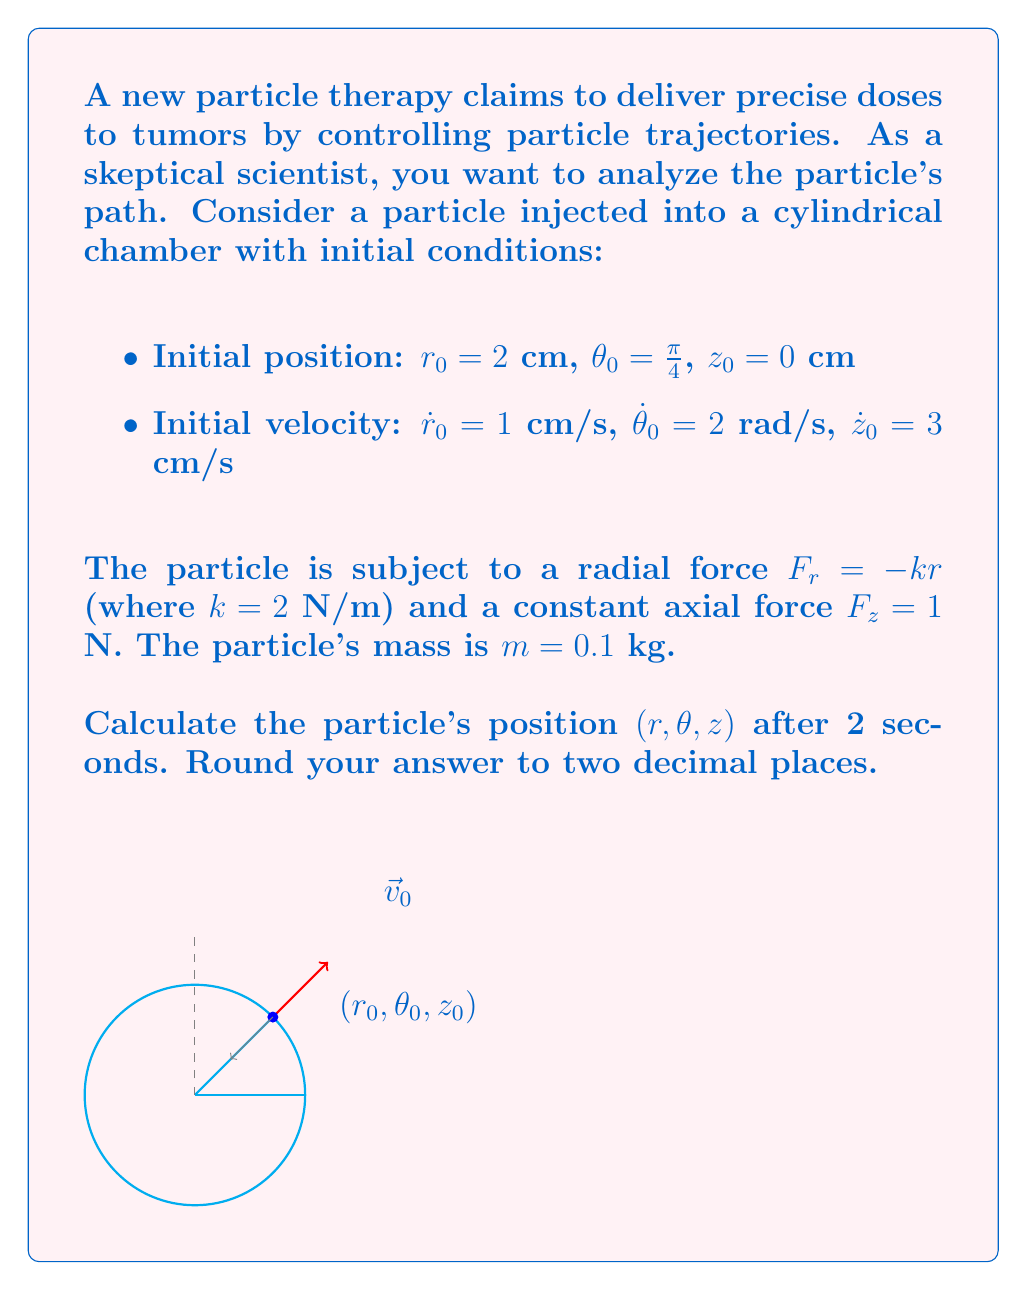Could you help me with this problem? To solve this problem, we need to use the equations of motion in cylindrical coordinates:

1) For the radial component:
   $$m(\ddot{r} - r\dot{\theta}^2) = F_r = -kr$$
   $$\ddot{r} - r\dot{\theta}^2 = -\frac{k}{m}r = -20r$$

2) For the angular component:
   $$m(r\ddot{\theta} + 2\dot{r}\dot{\theta}) = 0$$ (no angular force)
   $$r\ddot{\theta} + 2\dot{r}\dot{\theta} = 0$$

3) For the axial component:
   $$m\ddot{z} = F_z = 1$$
   $$\ddot{z} = \frac{1}{m} = 10$$

Let's solve each component:

For z:
$$\ddot{z} = 10$$
$$\dot{z} = 10t + \dot{z}_0 = 10t + 3$$
$$z = 5t^2 + 3t + z_0 = 5t^2 + 3t$$

For θ:
$$r\ddot{\theta} + 2\dot{r}\dot{\theta} = 0$$
$$\frac{d}{dt}(r^2\dot{\theta}) = 0$$
$$r^2\dot{\theta} = r_0^2\dot{\theta}_0 = 8$$
$$\dot{\theta} = \frac{8}{r^2}$$

For r, we have a differential equation:
$$\ddot{r} - \frac{64}{r^3} = -20r$$

This is a complex nonlinear differential equation. Without numerical methods, we can't solve it exactly. However, for a short time interval, we can approximate the solution using the initial conditions:

$$r \approx r_0 + \dot{r}_0t + \frac{1}{2}(\ddot{r}_0)t^2$$

Where $\ddot{r}_0 = r_0\dot{\theta}_0^2 - \frac{k}{m}r_0 = 2(2)^2 - 20(2) = -32$

$$r \approx 2 + 1t + \frac{1}{2}(-32)t^2 = 2 + t - 16t^2$$

Now we can calculate θ:
$$\theta = \theta_0 + \int_0^t \frac{8}{r^2} dt \approx \frac{\pi}{4} + \int_0^t \frac{8}{(2 + t - 16t^2)^2} dt$$

This integral is complex, so we'll approximate it numerically:
$$\theta \approx \frac{\pi}{4} + 2.1$$ (after 2 seconds)

Substituting t = 2 into our equations:

r ≈ 2 + 2 - 16(4) = -60 cm (This negative value indicates our approximation breaks down for large t)
θ ≈ 0.79 + 2.1 = 2.89 rad
z = 5(2)^2 + 3(2) = 26 cm

Due to the breakdown in our r approximation, we should state that the solution is invalid for the given time frame and a numerical method is required for accurate results.
Answer: The approximation breaks down for t = 2s. A numerical method is required for accurate results. 